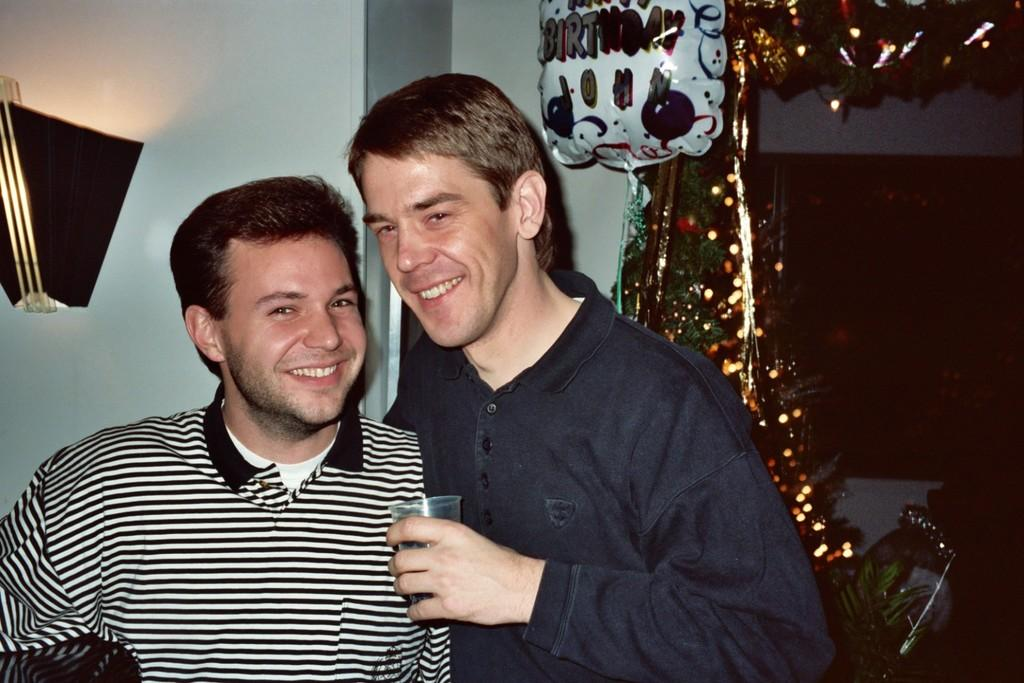How many people are in the image? There are two people in the image. What is the facial expression of the people in the image? Both people are smiling. What is one person holding in the image? One person is holding a glass. What can be seen behind the people in the image? There is a wall visible behind the people. What type of objects can be seen on the right side of the image? There are decorative items on the right side of the image. What type of bomb is visible on the left side of the image? There is no bomb present in the image. How many girls are in the image? The image does not specify the gender of the people, so we cannot determine if they are girls or not. 